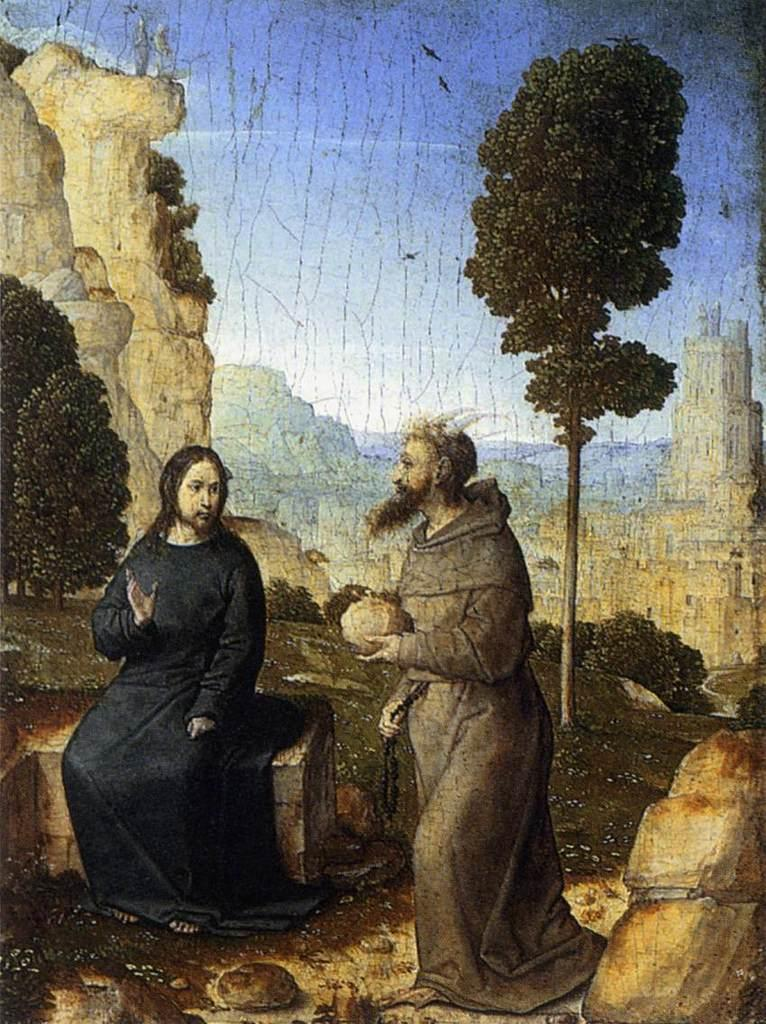What is depicted in the image? There is a painting in the image. Can you describe the scene in the painting? The painting features two persons, plants, a tree, and houses. What is visible in the background of the painting? There is a sky visible in the image. What type of war is depicted in the painting? There is no war depicted in the painting; it features a peaceful scene with two persons, plants, a tree, and houses. How many kittens are playing in the painting? There are no kittens present in the painting; it features a scene with two persons, plants, a tree, and houses. 